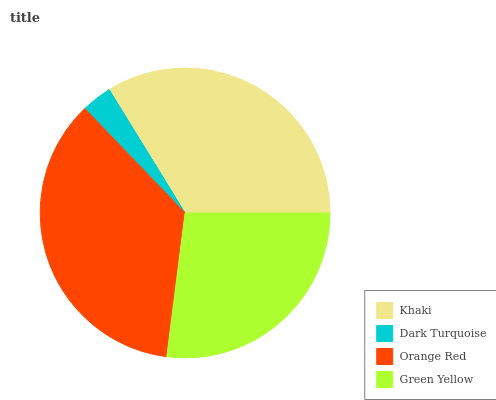Is Dark Turquoise the minimum?
Answer yes or no. Yes. Is Orange Red the maximum?
Answer yes or no. Yes. Is Orange Red the minimum?
Answer yes or no. No. Is Dark Turquoise the maximum?
Answer yes or no. No. Is Orange Red greater than Dark Turquoise?
Answer yes or no. Yes. Is Dark Turquoise less than Orange Red?
Answer yes or no. Yes. Is Dark Turquoise greater than Orange Red?
Answer yes or no. No. Is Orange Red less than Dark Turquoise?
Answer yes or no. No. Is Khaki the high median?
Answer yes or no. Yes. Is Green Yellow the low median?
Answer yes or no. Yes. Is Dark Turquoise the high median?
Answer yes or no. No. Is Orange Red the low median?
Answer yes or no. No. 